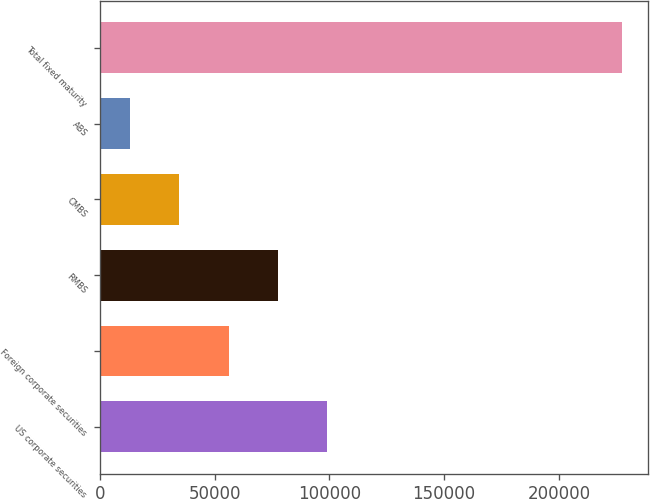Convert chart. <chart><loc_0><loc_0><loc_500><loc_500><bar_chart><fcel>US corporate securities<fcel>Foreign corporate securities<fcel>RMBS<fcel>CMBS<fcel>ABS<fcel>Total fixed maturity<nl><fcel>98954<fcel>56058<fcel>77506<fcel>34610<fcel>13162<fcel>227642<nl></chart> 